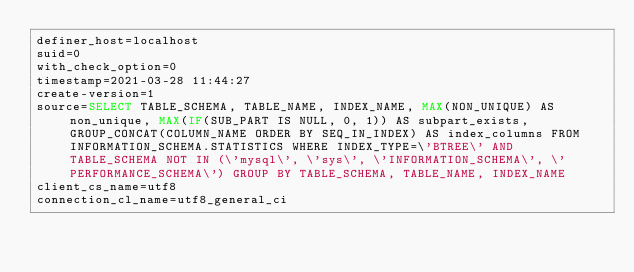Convert code to text. <code><loc_0><loc_0><loc_500><loc_500><_VisualBasic_>definer_host=localhost
suid=0
with_check_option=0
timestamp=2021-03-28 11:44:27
create-version=1
source=SELECT TABLE_SCHEMA, TABLE_NAME, INDEX_NAME, MAX(NON_UNIQUE) AS non_unique, MAX(IF(SUB_PART IS NULL, 0, 1)) AS subpart_exists, GROUP_CONCAT(COLUMN_NAME ORDER BY SEQ_IN_INDEX) AS index_columns FROM INFORMATION_SCHEMA.STATISTICS WHERE INDEX_TYPE=\'BTREE\' AND TABLE_SCHEMA NOT IN (\'mysql\', \'sys\', \'INFORMATION_SCHEMA\', \'PERFORMANCE_SCHEMA\') GROUP BY TABLE_SCHEMA, TABLE_NAME, INDEX_NAME
client_cs_name=utf8
connection_cl_name=utf8_general_ci</code> 